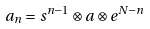Convert formula to latex. <formula><loc_0><loc_0><loc_500><loc_500>a _ { n } = s ^ { n - 1 } \otimes a \otimes e ^ { N - n }</formula> 